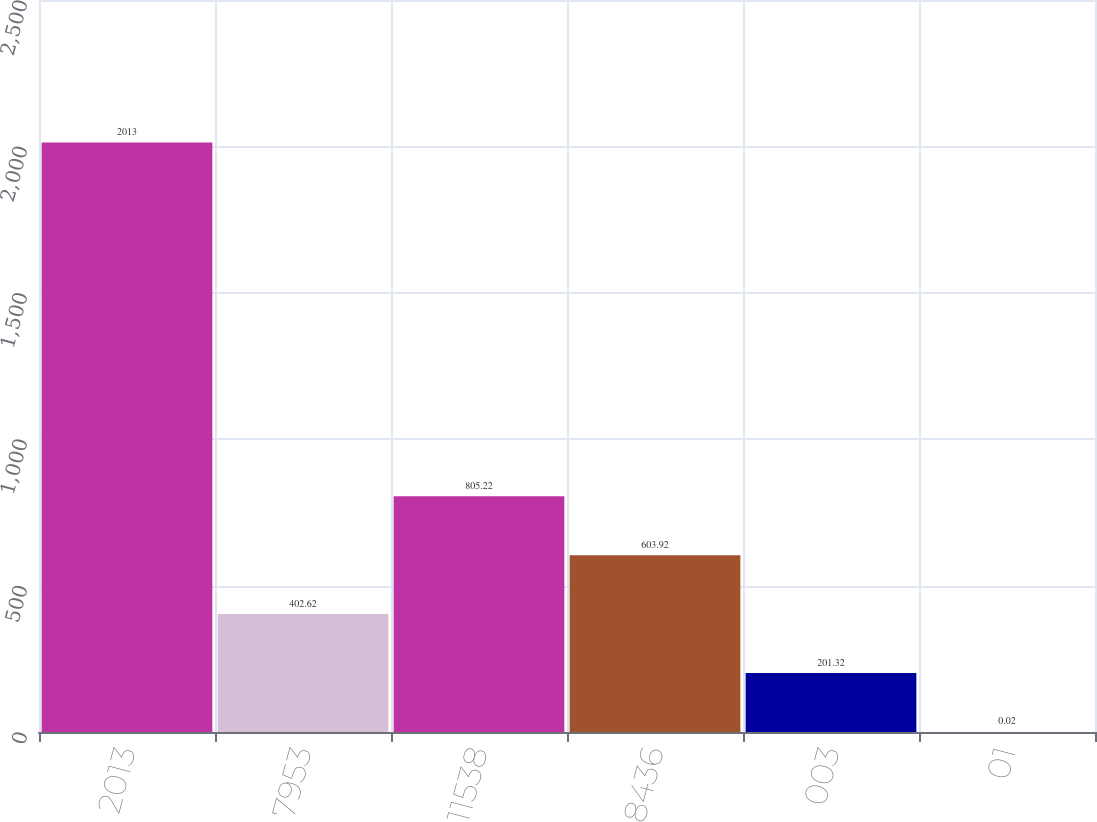Convert chart to OTSL. <chart><loc_0><loc_0><loc_500><loc_500><bar_chart><fcel>2013<fcel>7953<fcel>11538<fcel>8436<fcel>003<fcel>01<nl><fcel>2013<fcel>402.62<fcel>805.22<fcel>603.92<fcel>201.32<fcel>0.02<nl></chart> 